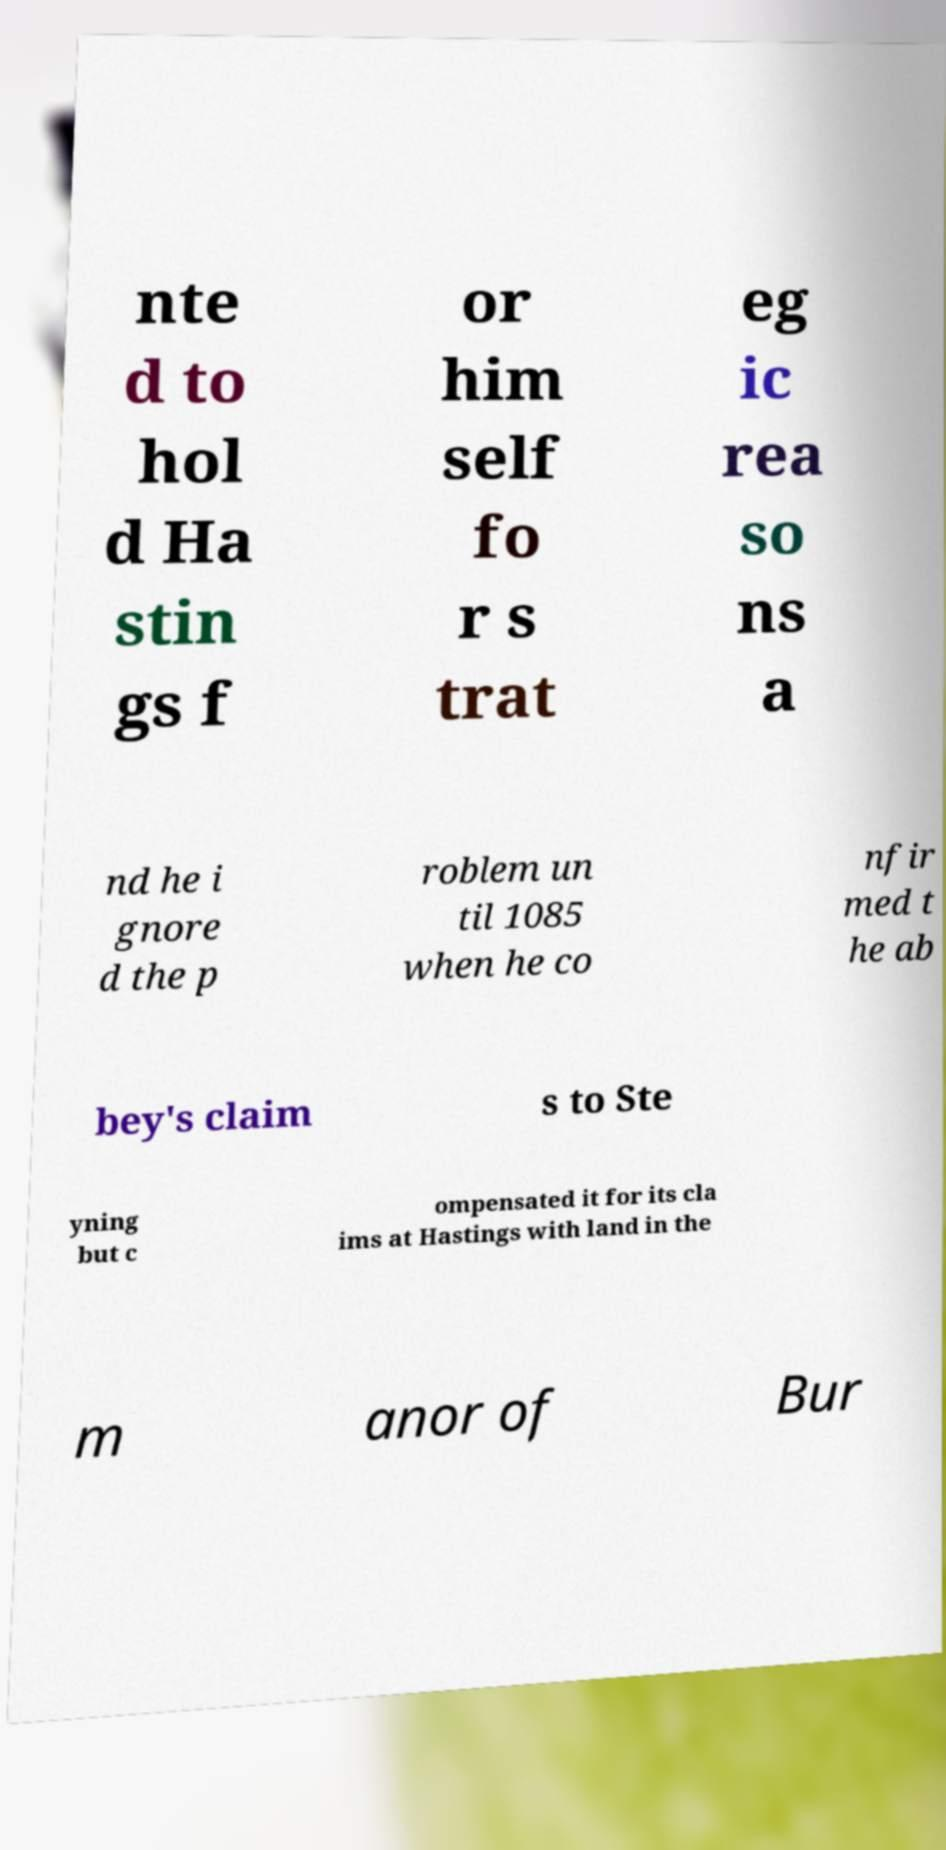Could you assist in decoding the text presented in this image and type it out clearly? nte d to hol d Ha stin gs f or him self fo r s trat eg ic rea so ns a nd he i gnore d the p roblem un til 1085 when he co nfir med t he ab bey's claim s to Ste yning but c ompensated it for its cla ims at Hastings with land in the m anor of Bur 